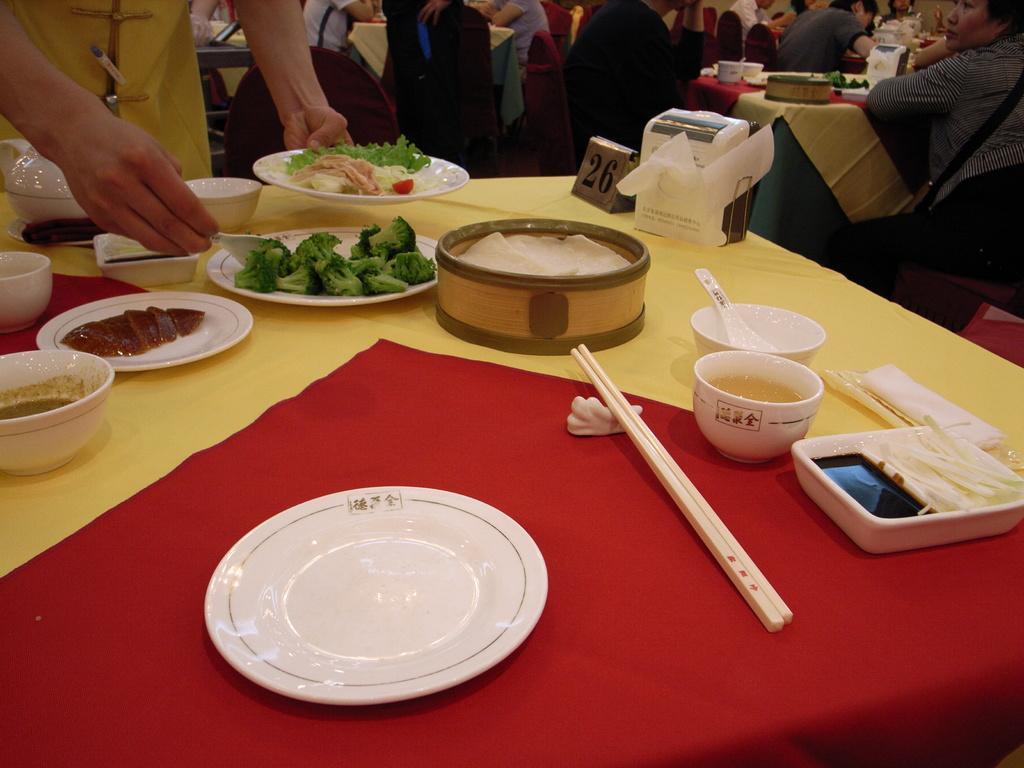Please provide a concise description of this image. In this image I can see there is a white color plate on this table and on the right side there is a chopstick. In the middle there are broccoli pieces in the plate. On the left side a human is mixing these things. On the right side few people are sitting around the chairs. 